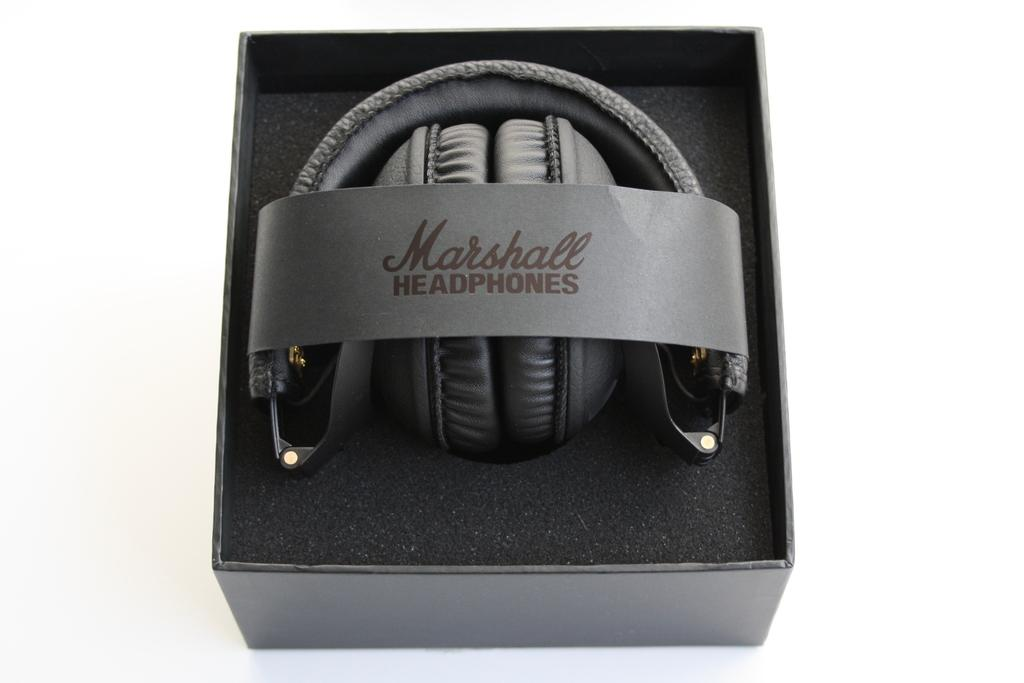What objects are contained within the box in the image? There are headsets in a box in the image. What other items can be seen in the image besides the headsets? There is a sponge and a paper in the image. What is written on the paper? There is text on the paper. On what surface is the box placed? The box is placed on a white surface. What type of shoe is visible on the roof in the image? There is no shoe or roof present in the image. What kind of lunch is being prepared in the image? There is no indication of any lunch preparation in the image. 